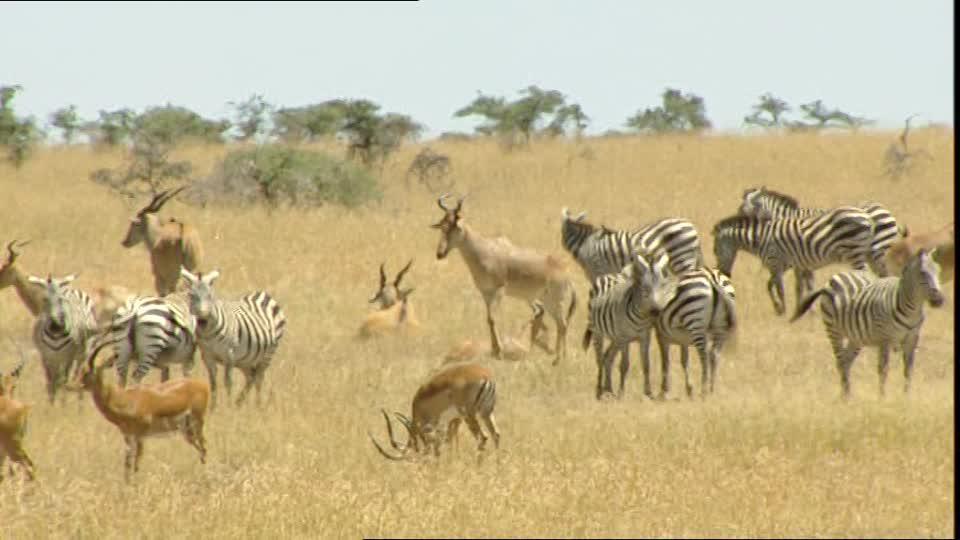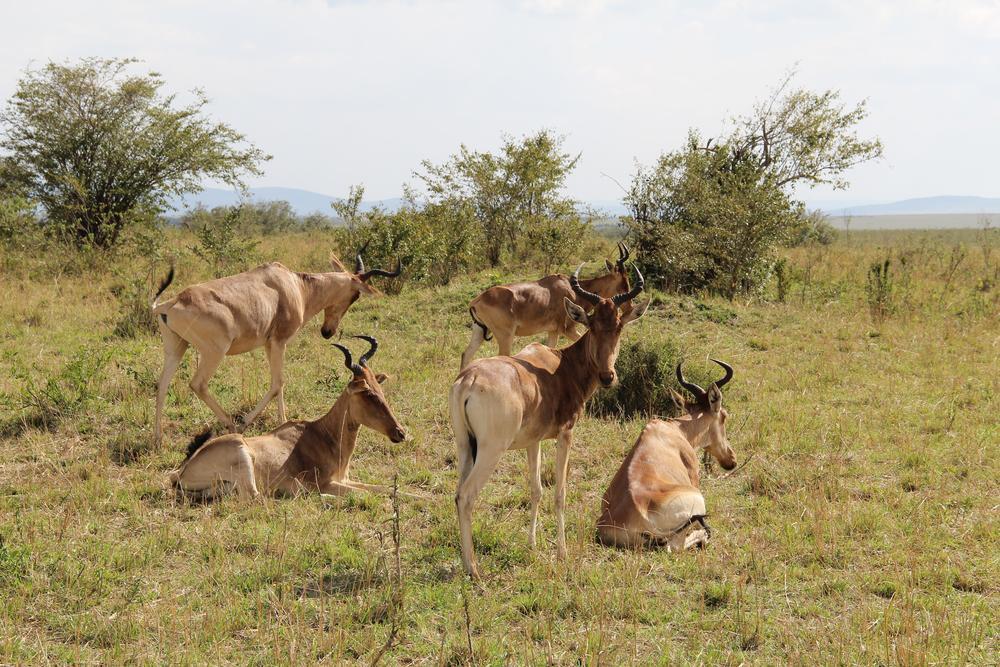The first image is the image on the left, the second image is the image on the right. Given the left and right images, does the statement "No photo contains more than one animal." hold true? Answer yes or no. No. The first image is the image on the left, the second image is the image on the right. Assess this claim about the two images: "There are more than two standing animals.". Correct or not? Answer yes or no. Yes. 